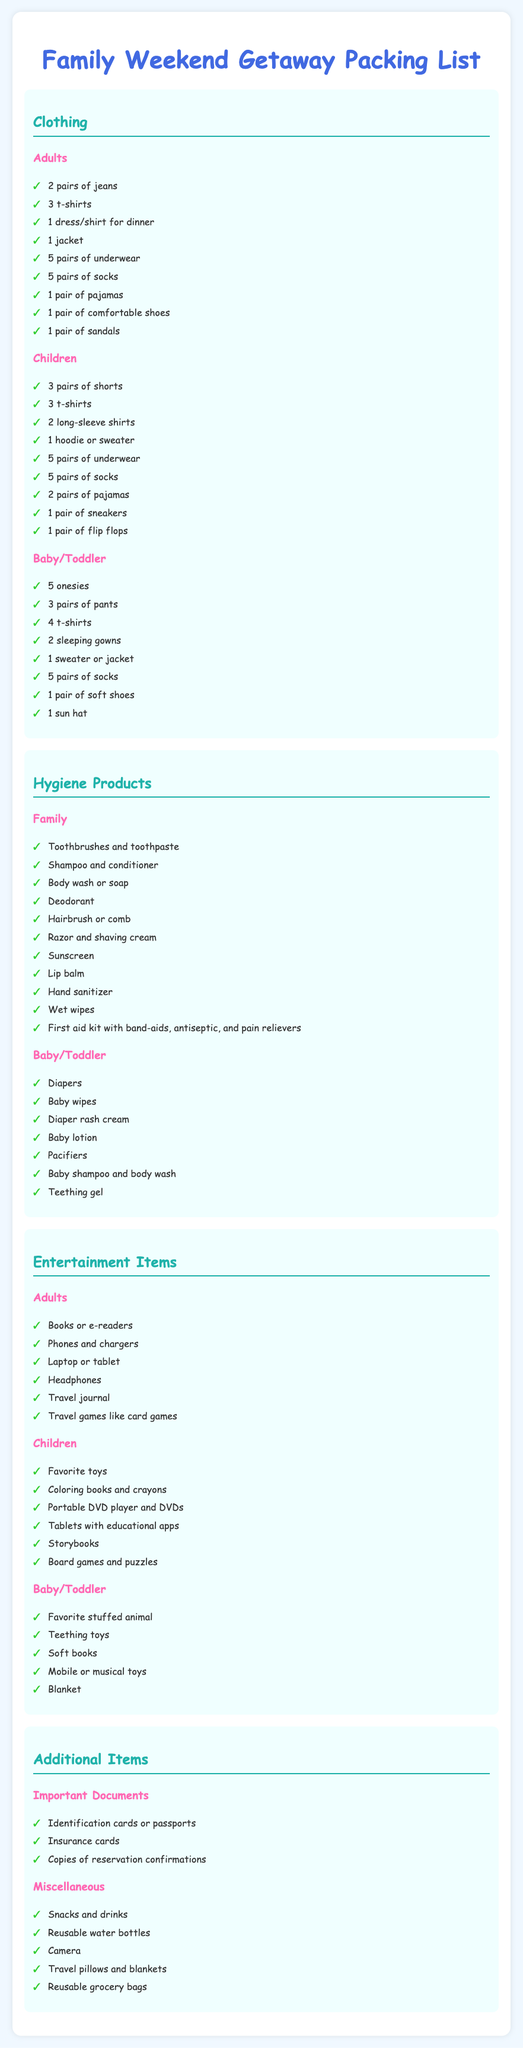What clothing item is listed for children that is not for adults? The document lists specific clothing items for each category, and "3 pairs of shorts" is included for children only.
Answer: 3 pairs of shorts How many pairs of underwear should adults pack? Under the Adults section, it clearly states the number of underwear to pack, which is 5 pairs.
Answer: 5 pairs What hygiene product is specifically for a baby/toddler? The hygiene section lists specific items for baby/toddler care, such as "Diapers."
Answer: Diapers What is included in the Entertainment Items for children? The children’s section under Entertainment Items includes a variety of items, one of which is "Coloring books and crayons."
Answer: Coloring books and crayons How many pairs of socks should a baby/toddler bring? The document specifies the sock quantity under the Baby/Toddler section, which is 5 pairs.
Answer: 5 pairs What item is mentioned for adults to document their trip? Among the adult entertainment items, "Travel journal" is specified as a way to document the trip.
Answer: Travel journal How many important documents should be packed? The Important Documents section lists three key items that should be packed, indicating the effort to ensure essential documentation.
Answer: 3 What hygiene product is listed for sun protection? The hygiene section mentions "Sunscreen" as an essential product for sun protection.
Answer: Sunscreen Which type of shoes should children pack aside from sneakers? The packing list for children includes "1 pair of flip flops" as additional footwear.
Answer: 1 pair of flip flops 